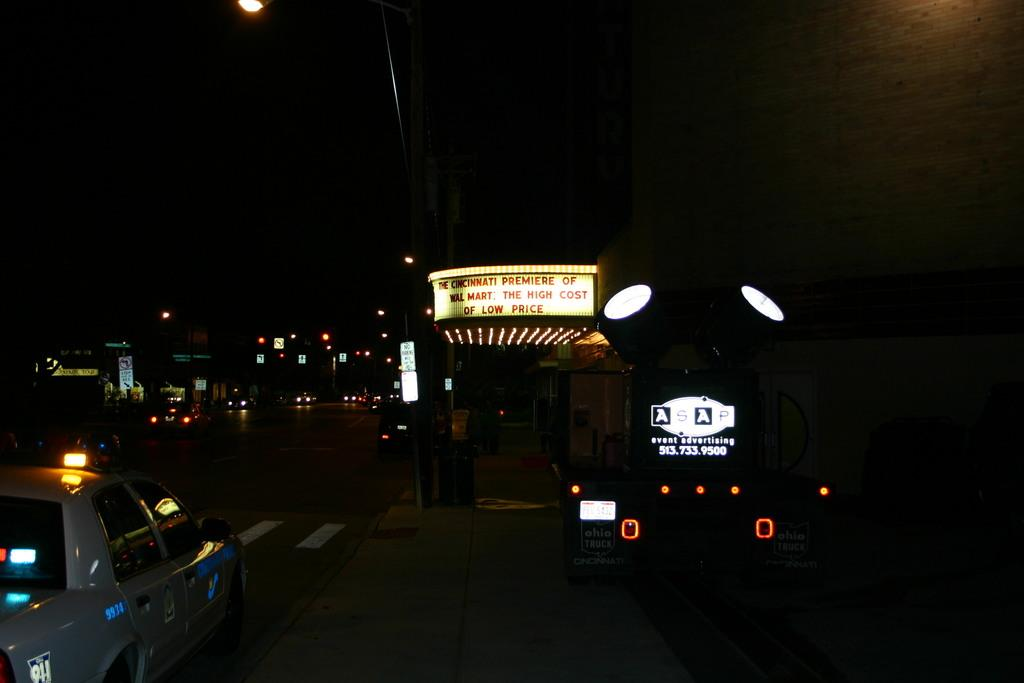<image>
Render a clear and concise summary of the photo. A dark street with a marquee that tells of a premiere. 